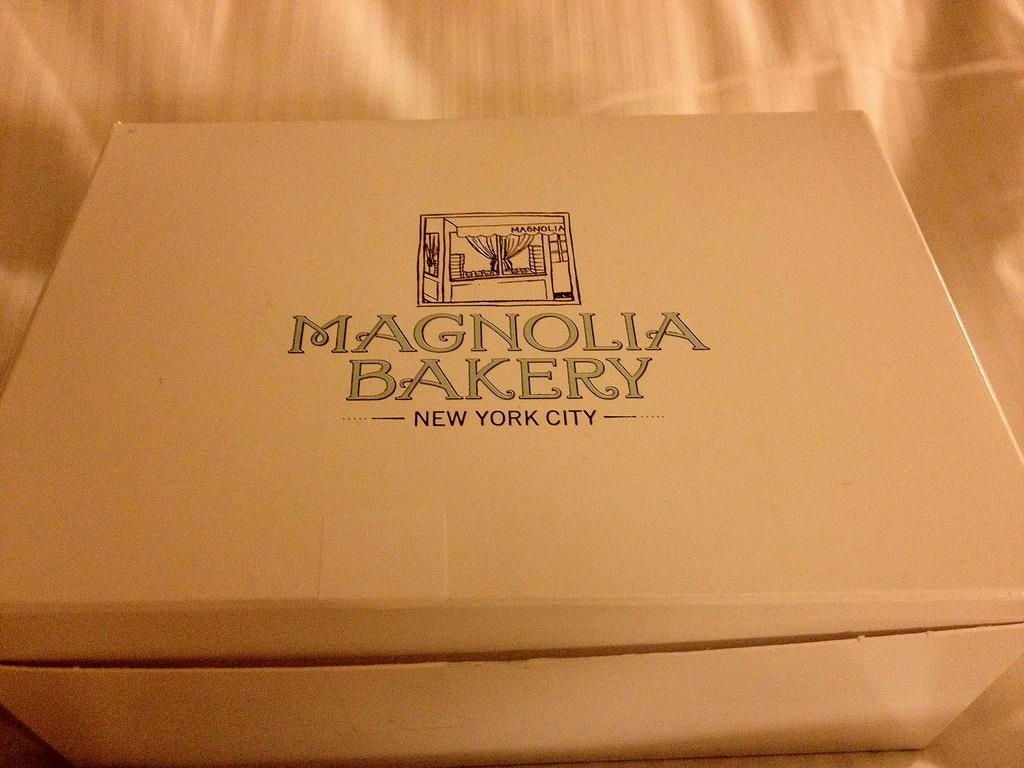Provide a one-sentence caption for the provided image. Box for Magnolia Bakery in New York City. 